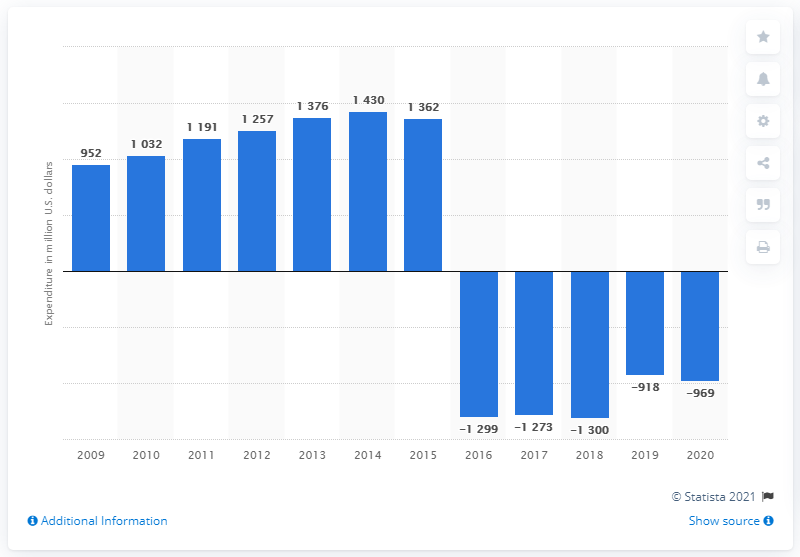Point out several critical features in this image. In 2013, Syngenta invested 1,376 million U.S. dollars in research and development. 